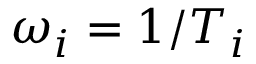Convert formula to latex. <formula><loc_0><loc_0><loc_500><loc_500>\omega _ { i } = 1 / T _ { i }</formula> 